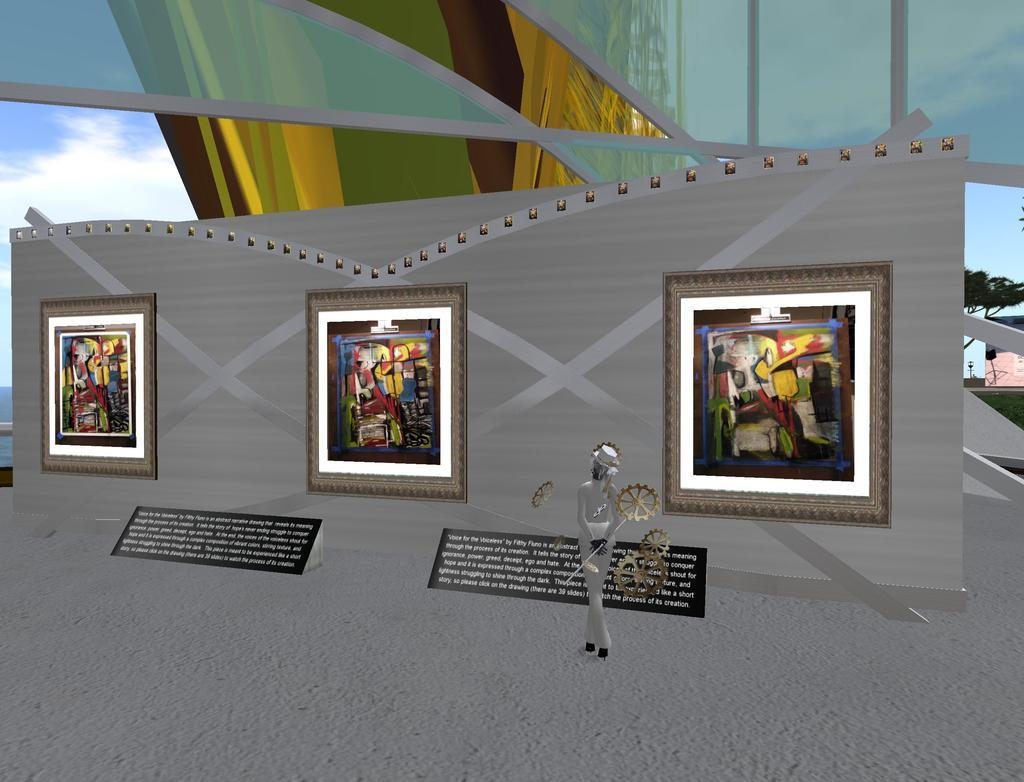Can you describe the main subject of the image? Unfortunately, there are no specific facts provided about the image, so it is impossible to describe the main subject or any other details. How many trucks are parked in front of the store in the image? There is no information about trucks, a store, or any other subjects in the image, so it is impossible to answer this question. 